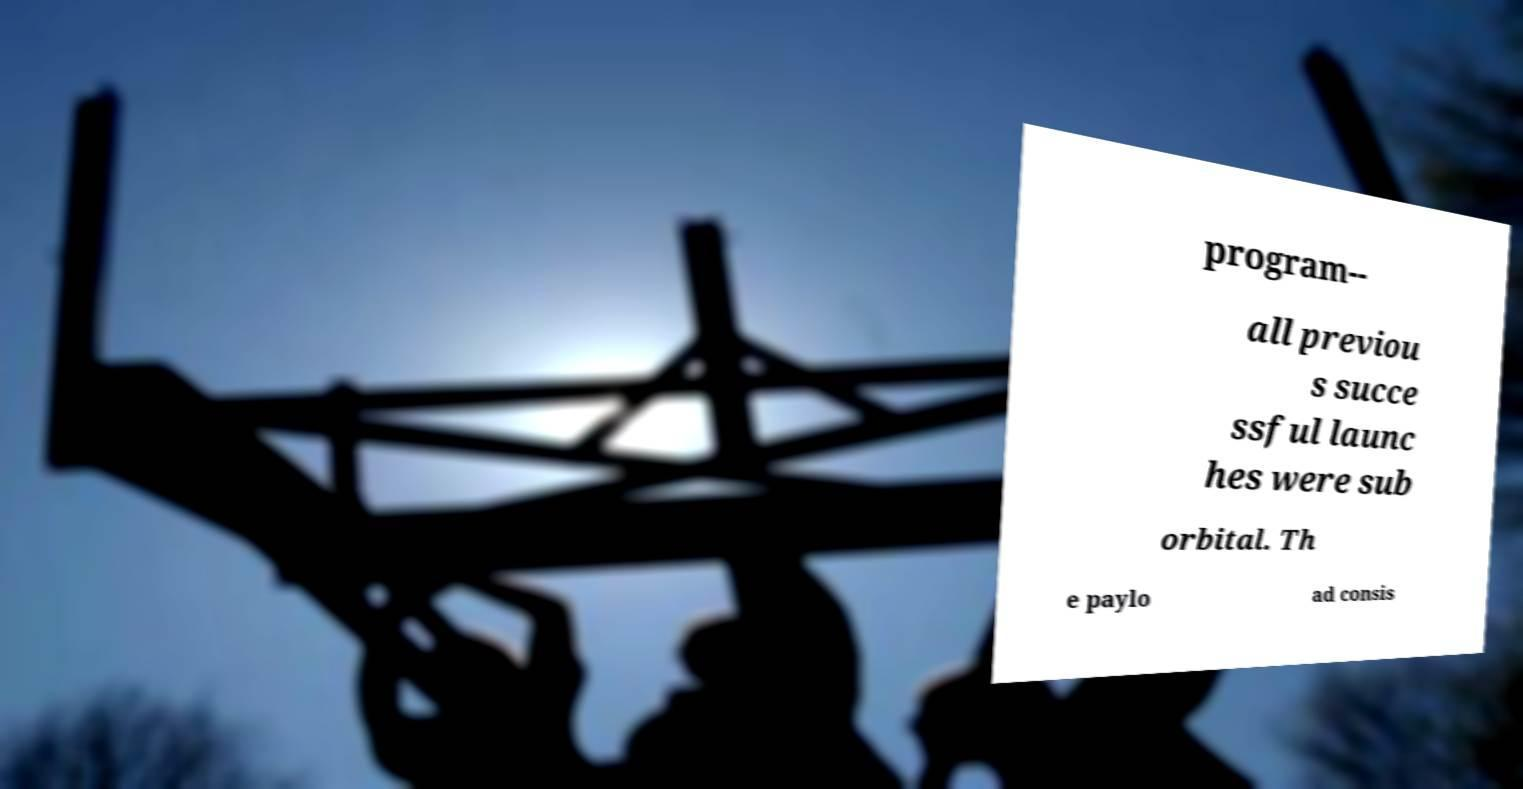Please identify and transcribe the text found in this image. program-- all previou s succe ssful launc hes were sub orbital. Th e paylo ad consis 